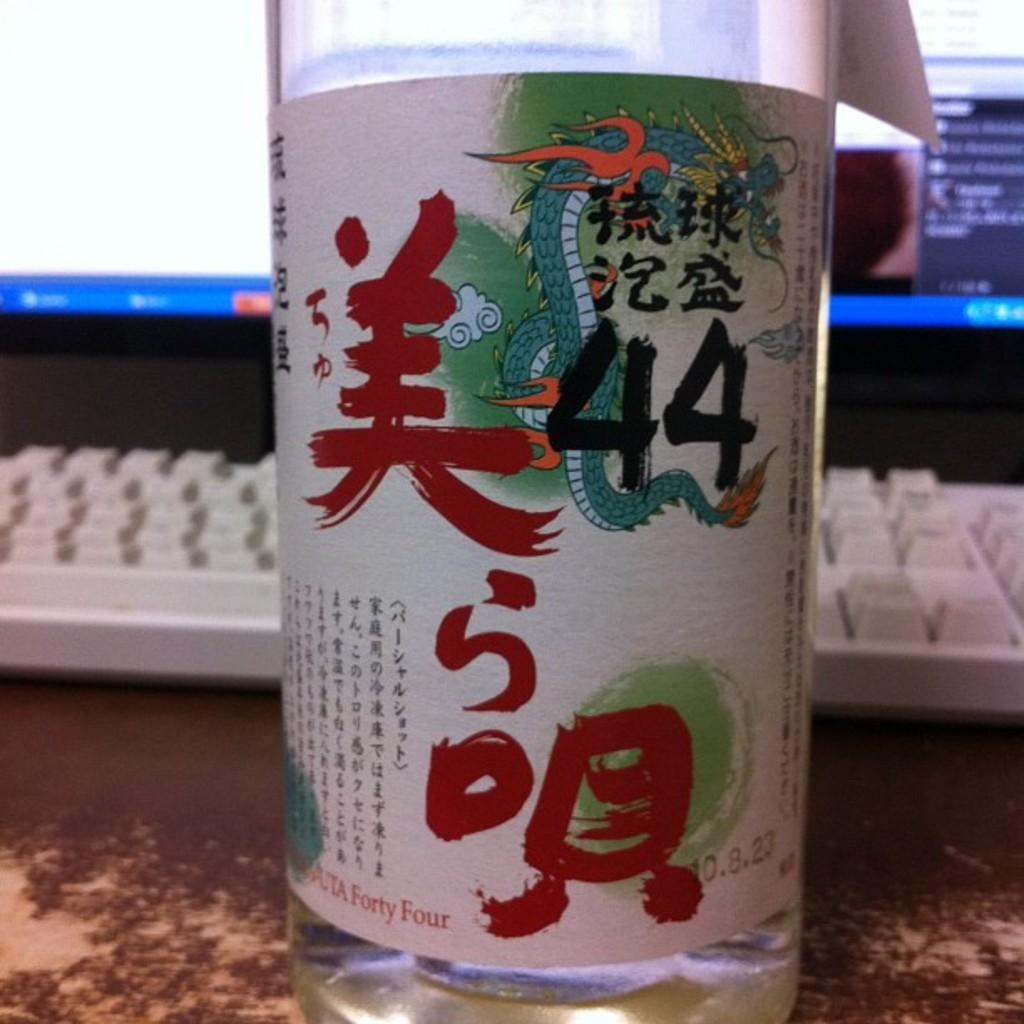Provide a one-sentence caption for the provided image. A glass written in japanese with fourty four noted of importance in front of a computer keyboard. 